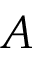<formula> <loc_0><loc_0><loc_500><loc_500>A</formula> 